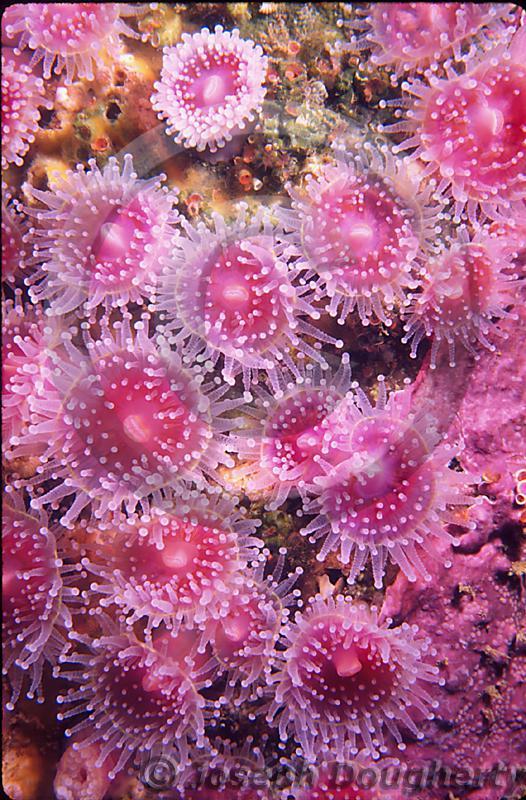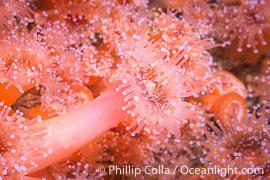The first image is the image on the left, the second image is the image on the right. Examine the images to the left and right. Is the description "One image shows a mass of violet-colored anemones, and the other image shows a mass of anemone with orangish-coral color and visible white dots at the end of each tendril." accurate? Answer yes or no. Yes. The first image is the image on the left, the second image is the image on the right. Analyze the images presented: Is the assertion "In the image to the left, the creature clearly has a green tint to it." valid? Answer yes or no. No. 